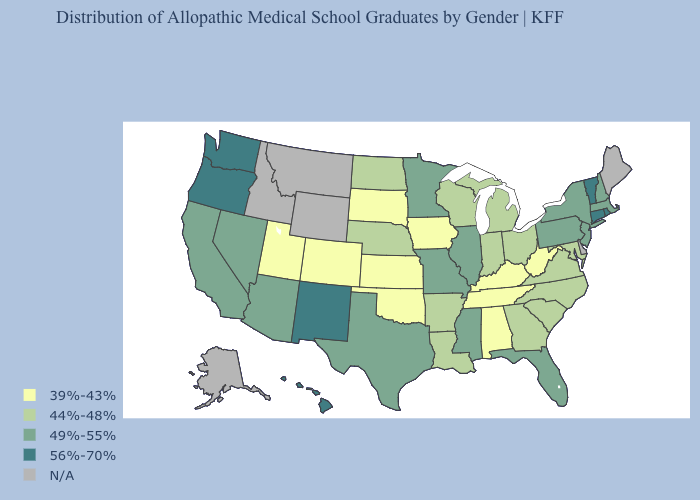Name the states that have a value in the range 49%-55%?
Short answer required. Arizona, California, Florida, Illinois, Massachusetts, Minnesota, Mississippi, Missouri, Nevada, New Hampshire, New Jersey, New York, Pennsylvania, Texas. Among the states that border Oregon , which have the highest value?
Short answer required. Washington. Which states have the lowest value in the West?
Keep it brief. Colorado, Utah. What is the lowest value in the West?
Answer briefly. 39%-43%. What is the value of Idaho?
Concise answer only. N/A. Does West Virginia have the lowest value in the South?
Write a very short answer. Yes. Which states have the lowest value in the Northeast?
Answer briefly. Massachusetts, New Hampshire, New Jersey, New York, Pennsylvania. What is the value of Washington?
Answer briefly. 56%-70%. Name the states that have a value in the range 49%-55%?
Quick response, please. Arizona, California, Florida, Illinois, Massachusetts, Minnesota, Mississippi, Missouri, Nevada, New Hampshire, New Jersey, New York, Pennsylvania, Texas. What is the value of Illinois?
Be succinct. 49%-55%. What is the value of Virginia?
Keep it brief. 44%-48%. Name the states that have a value in the range 39%-43%?
Quick response, please. Alabama, Colorado, Iowa, Kansas, Kentucky, Oklahoma, South Dakota, Tennessee, Utah, West Virginia. What is the value of Maryland?
Keep it brief. 44%-48%. Among the states that border Pennsylvania , does Maryland have the lowest value?
Quick response, please. No. What is the lowest value in the MidWest?
Give a very brief answer. 39%-43%. 